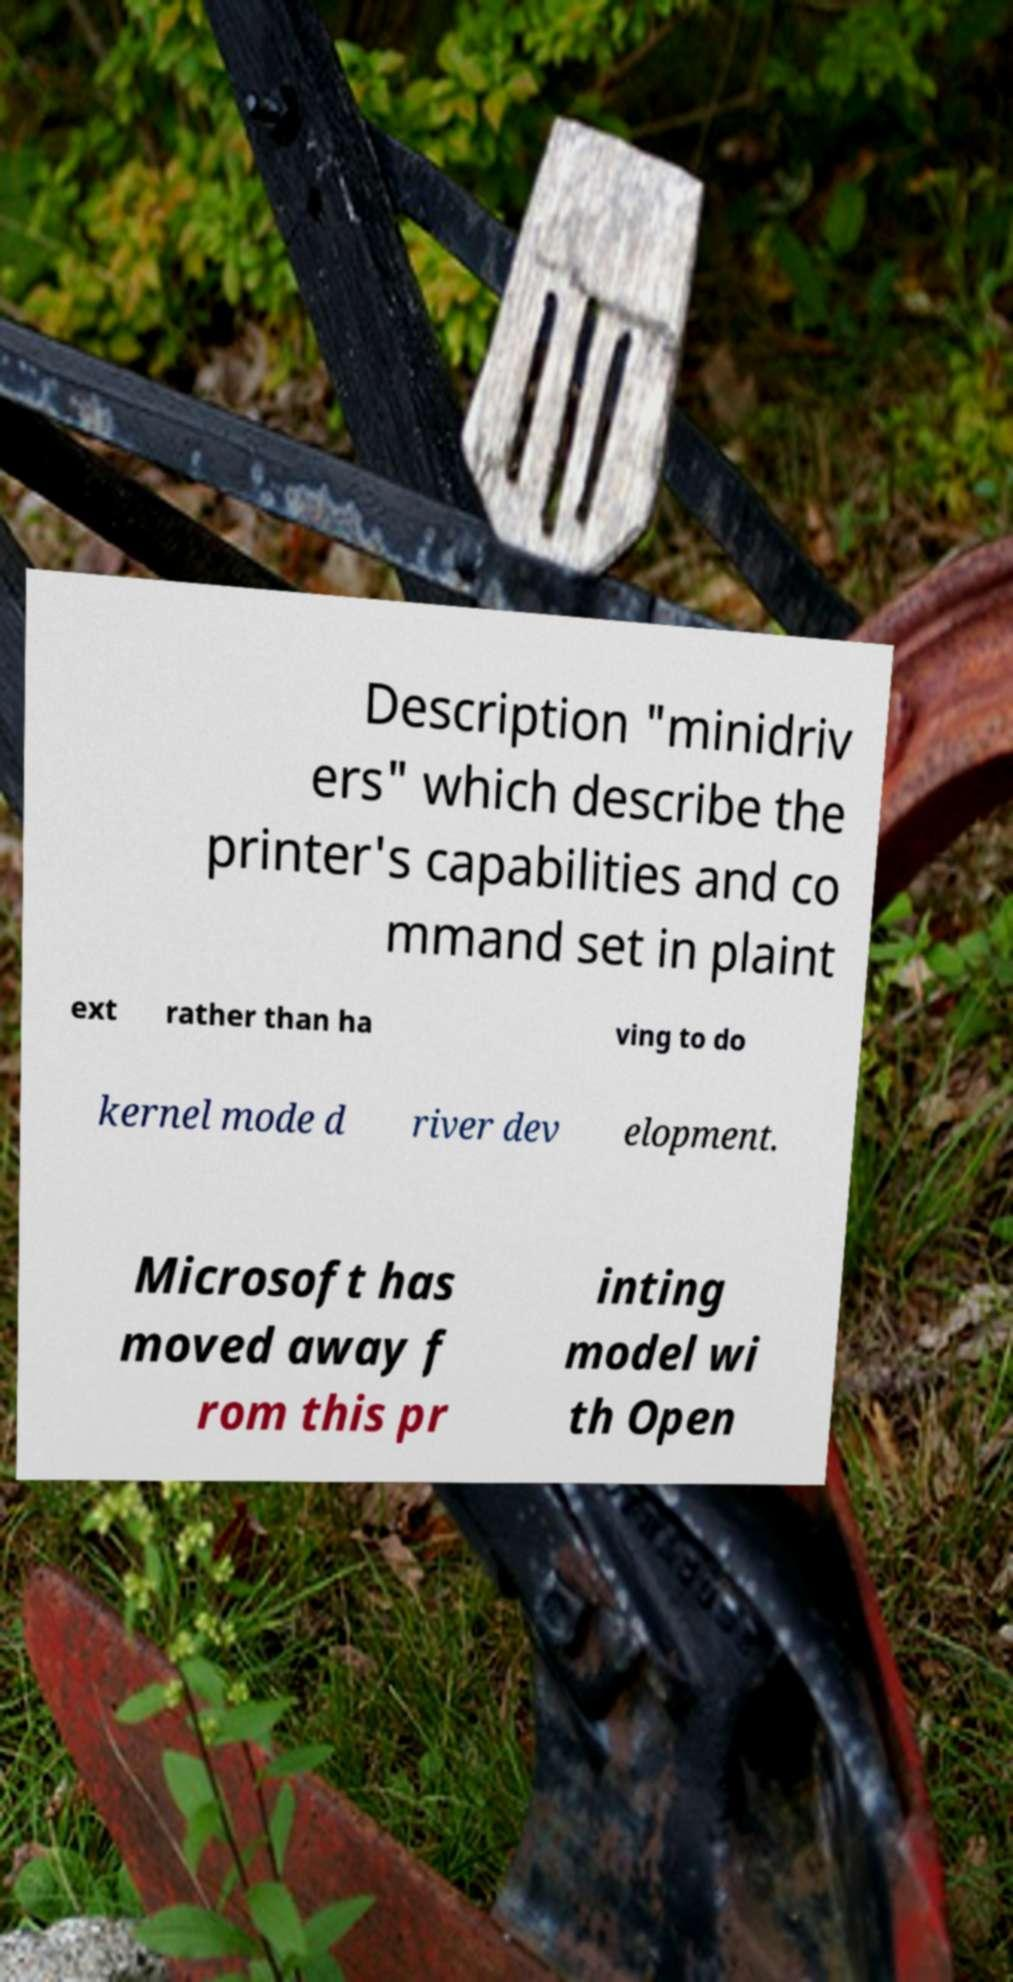What messages or text are displayed in this image? I need them in a readable, typed format. Description "minidriv ers" which describe the printer's capabilities and co mmand set in plaint ext rather than ha ving to do kernel mode d river dev elopment. Microsoft has moved away f rom this pr inting model wi th Open 